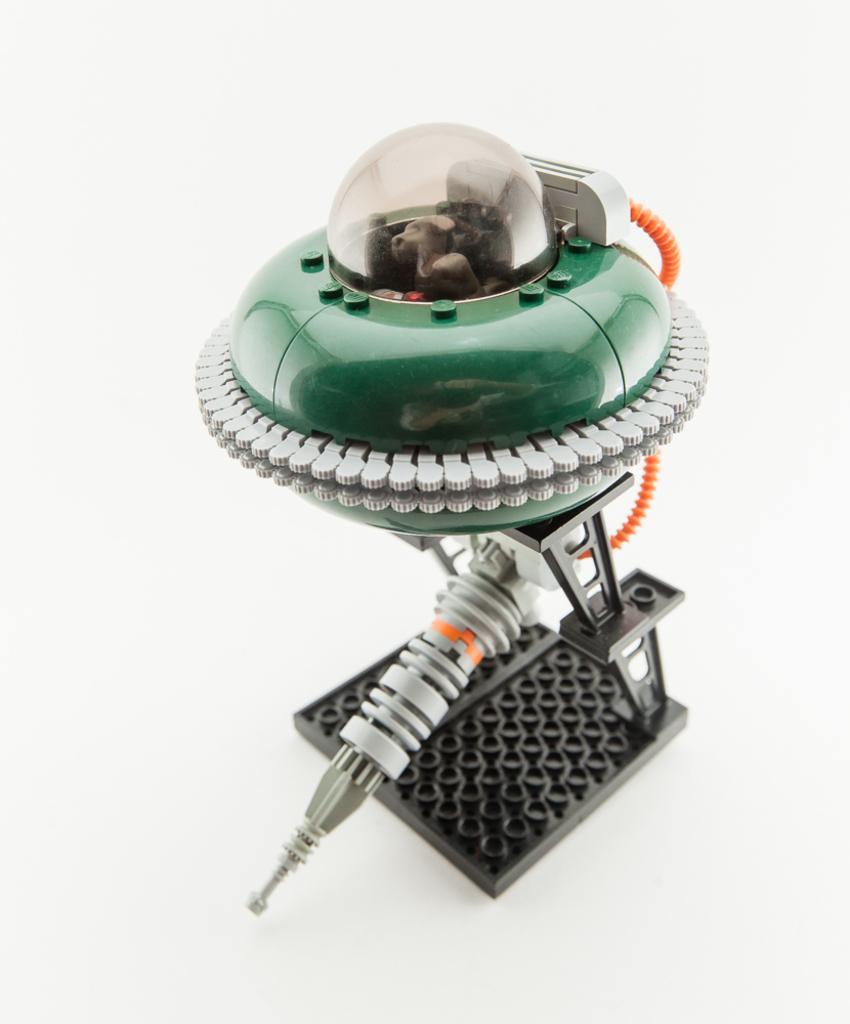Can you describe this image briefly? In this image we can see an object, which looks like a robot and the background is white. 